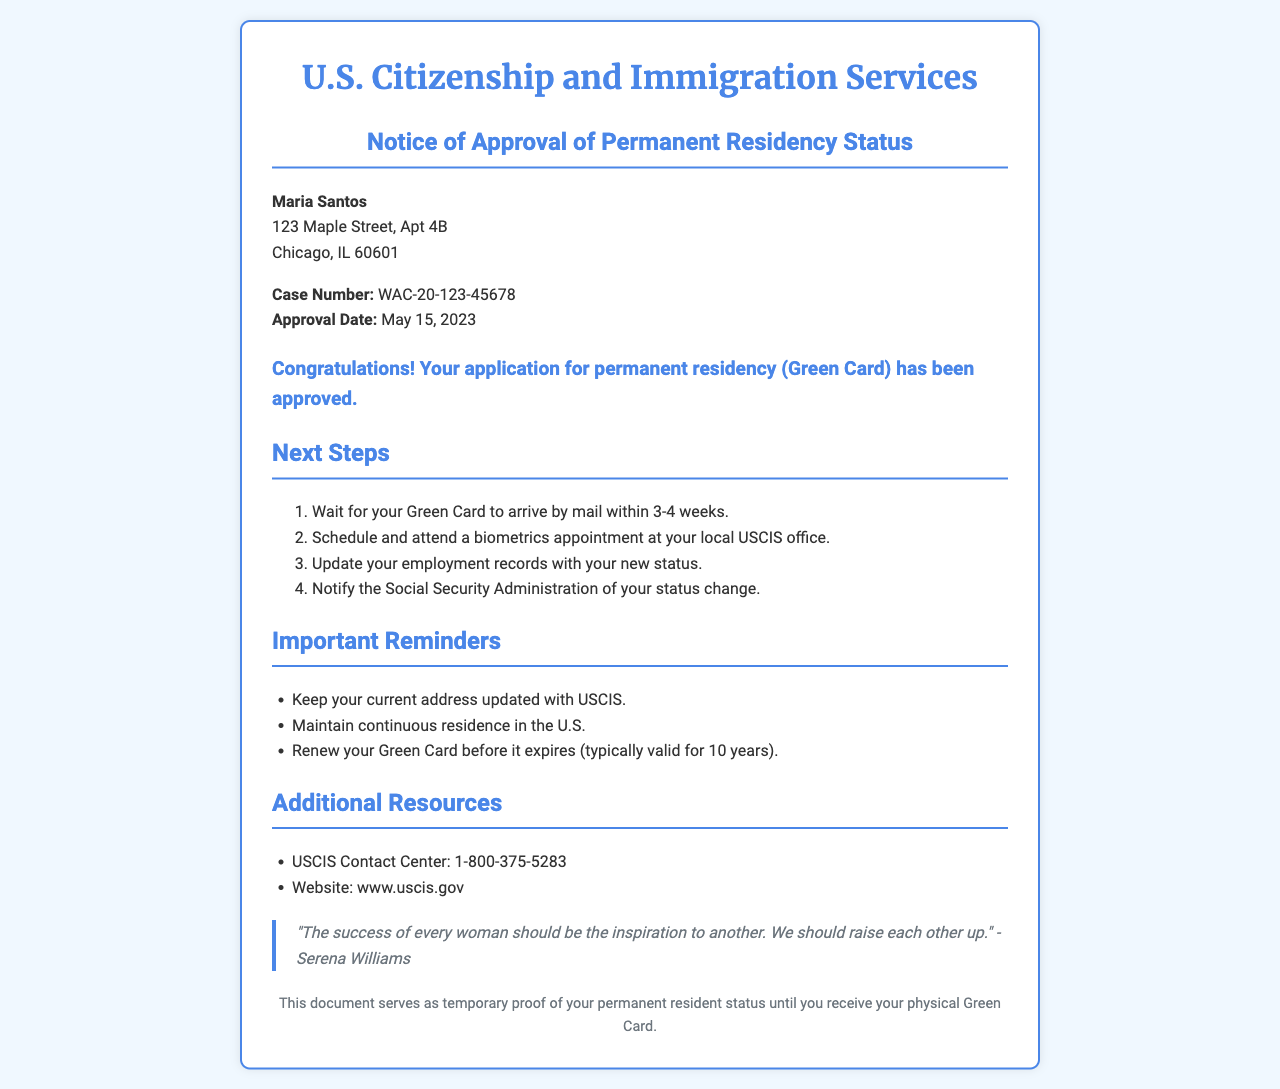What is the recipient's name? The recipient's name is shown at the beginning of the document in the recipient information section.
Answer: Maria Santos What is the case number? The case number is specified in the recipient information section, providing a unique identifier for the application.
Answer: WAC-20-123-45678 When was the approval date? The approval date is noted in the case information within the document.
Answer: May 15, 2023 What are the first two next steps listed? The next steps involve waiting for the Green Card and scheduling a biometrics appointment, outlined in the next steps section.
Answer: Wait for your Green Card to arrive by mail and Schedule and attend a biometrics appointment How long should one wait for the Green Card to arrive? The document includes this information in the next steps, indicating the expected time frame for delivery.
Answer: 3-4 weeks What should be done with employment records? This is addressed in the next steps section, stating the necessary update regarding residency.
Answer: Update your employment records with your new status How often should one renew their Green Card? The document provides a reminder about renewal timing, a critical aspect of maintaining residency status.
Answer: Typically valid for 10 years What is the USCIS Contact Center number? The contact information section lists important resources, including this phone number for inquiries.
Answer: 1-800-375-5283 What is the purpose of this document? The footer explains the role of this document, clarifying its use until the Green Card is received.
Answer: Temporary proof of your permanent resident status 